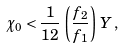<formula> <loc_0><loc_0><loc_500><loc_500>\chi _ { 0 } < \frac { 1 } { 1 2 } \, \left ( \frac { f _ { 2 } } { f _ { 1 } } \right ) \, Y \, ,</formula> 